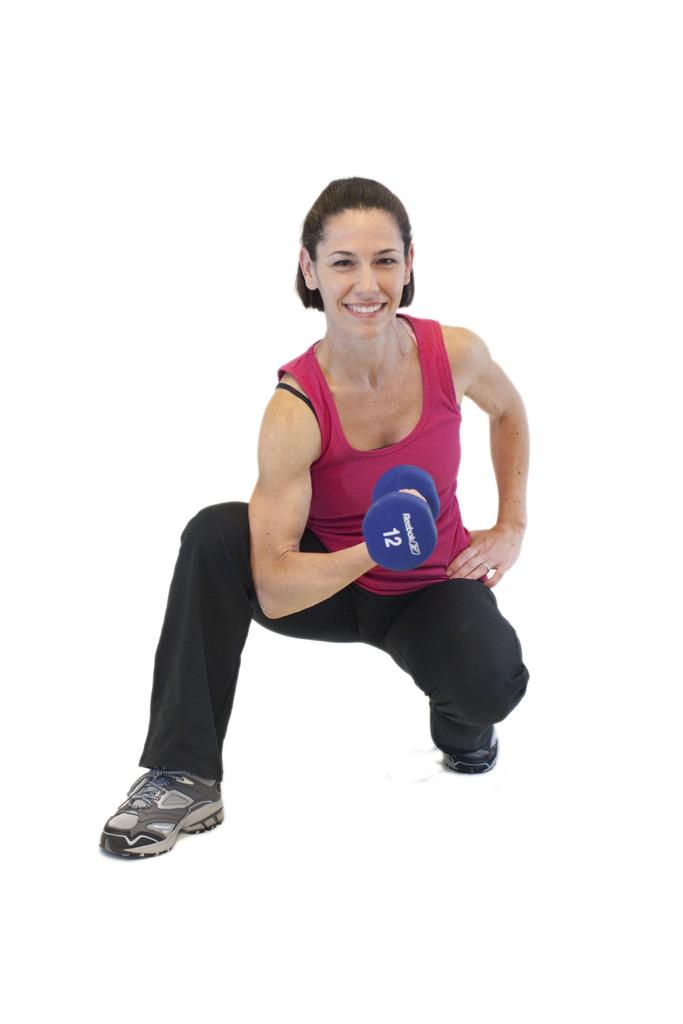What is the main subject of the image? There is a person in the image. How is the person positioned in the image? The person is sitting in a squatting position. What is the person holding in her hand? The person is holding a dumbbell in her hand. What type of statement is the person making in the image? There is no indication in the image that the person is making a statement. Can you see a collar on the person in the image? There is no collar visible on the person in the image. 